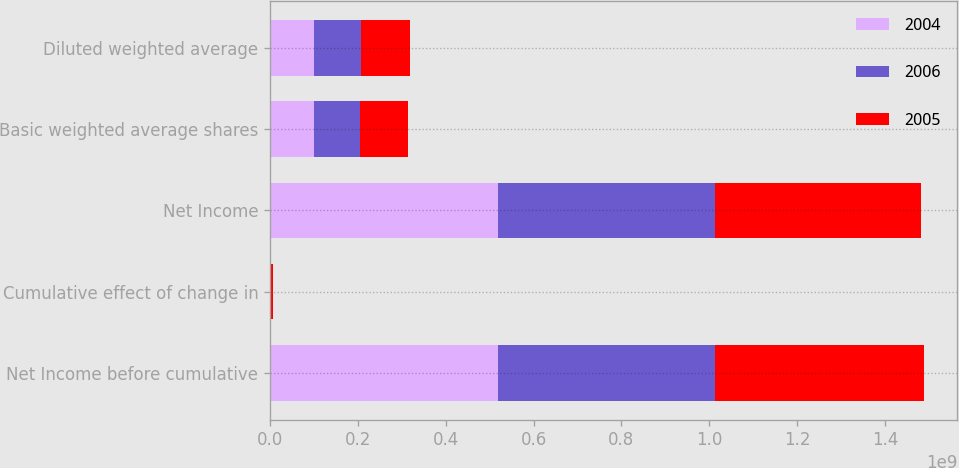<chart> <loc_0><loc_0><loc_500><loc_500><stacked_bar_chart><ecel><fcel>Net Income before cumulative<fcel>Cumulative effect of change in<fcel>Net Income<fcel>Basic weighted average shares<fcel>Diluted weighted average<nl><fcel>2004<fcel>5.18631e+08<fcel>0<fcel>5.18631e+08<fcel>9.97326e+07<fcel>1.01112e+08<nl><fcel>2006<fcel>4.9539e+08<fcel>0<fcel>4.9539e+08<fcel>1.04735e+08<fcel>1.05751e+08<nl><fcel>2005<fcel>4.75718e+08<fcel>7.163e+06<fcel>4.68555e+08<fcel>1.10106e+08<fcel>1.11908e+08<nl></chart> 